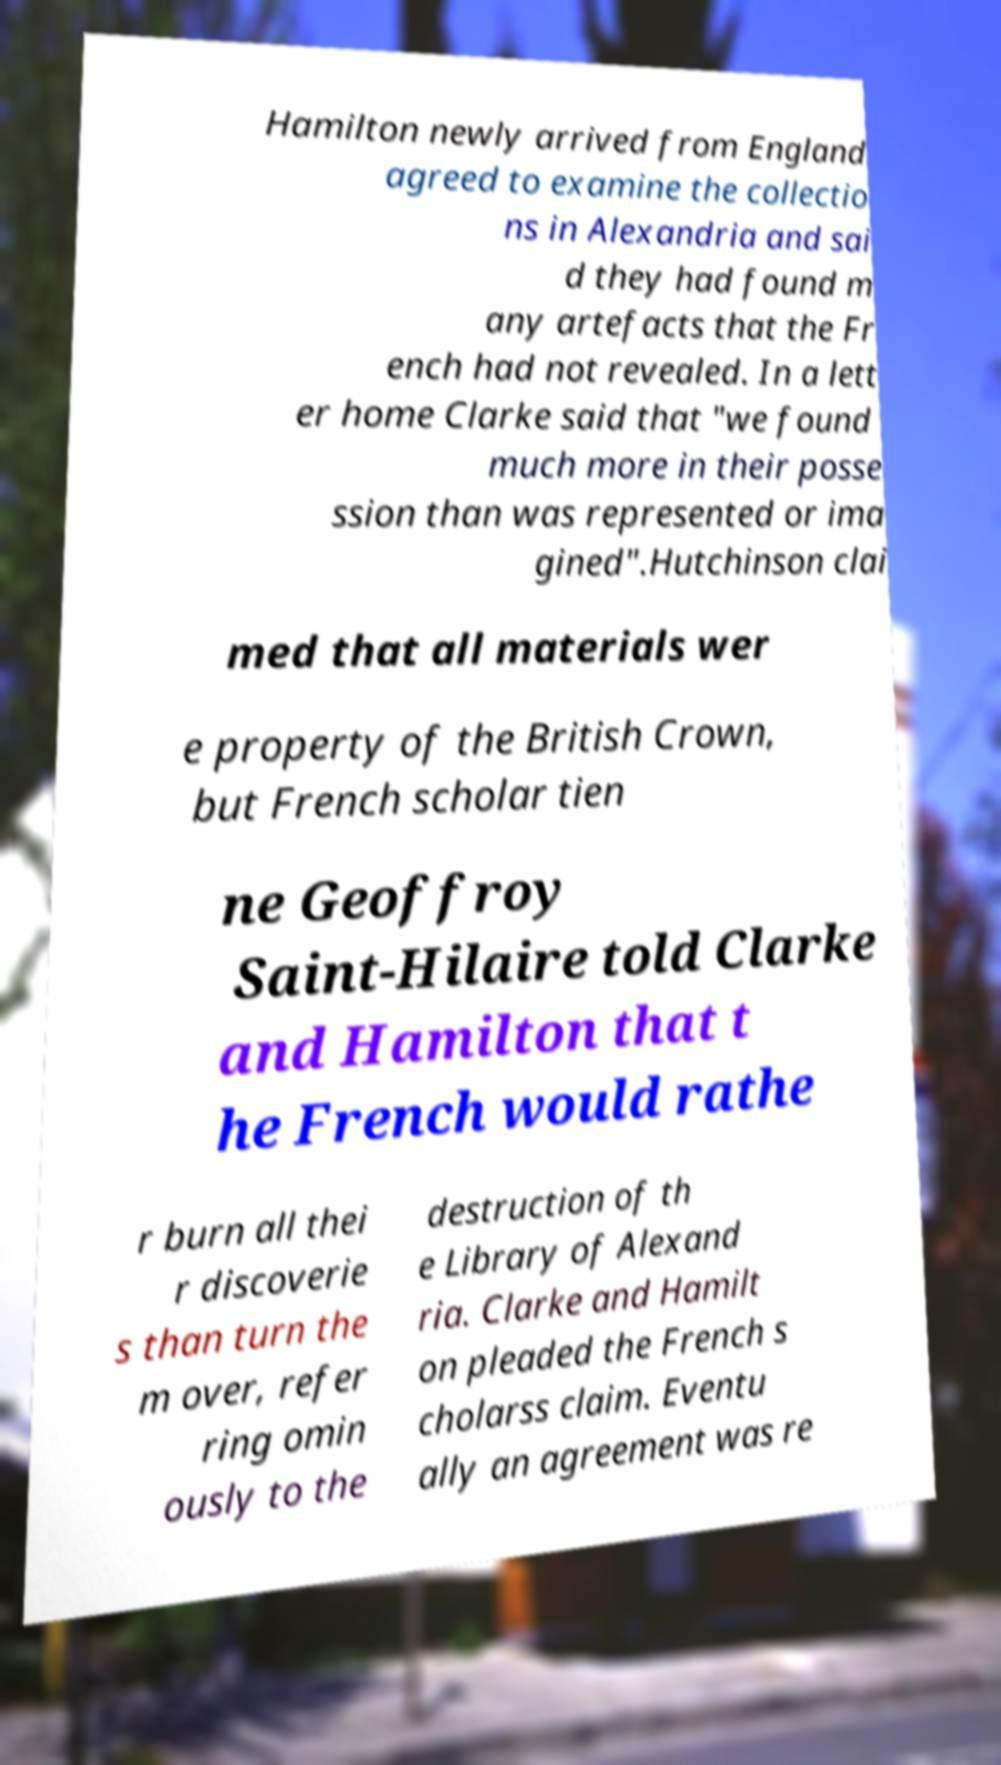Could you assist in decoding the text presented in this image and type it out clearly? Hamilton newly arrived from England agreed to examine the collectio ns in Alexandria and sai d they had found m any artefacts that the Fr ench had not revealed. In a lett er home Clarke said that "we found much more in their posse ssion than was represented or ima gined".Hutchinson clai med that all materials wer e property of the British Crown, but French scholar tien ne Geoffroy Saint-Hilaire told Clarke and Hamilton that t he French would rathe r burn all thei r discoverie s than turn the m over, refer ring omin ously to the destruction of th e Library of Alexand ria. Clarke and Hamilt on pleaded the French s cholarss claim. Eventu ally an agreement was re 